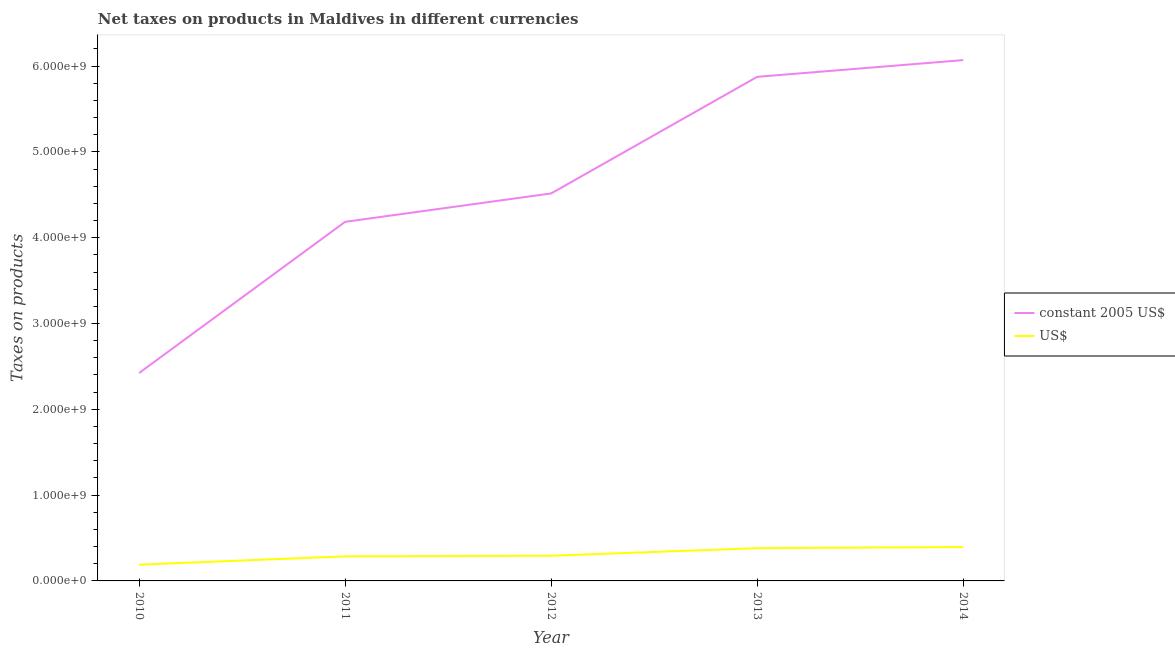What is the net taxes in constant 2005 us$ in 2012?
Your answer should be very brief. 4.52e+09. Across all years, what is the maximum net taxes in us$?
Provide a short and direct response. 3.94e+08. Across all years, what is the minimum net taxes in us$?
Your response must be concise. 1.89e+08. In which year was the net taxes in us$ maximum?
Make the answer very short. 2014. What is the total net taxes in us$ in the graph?
Provide a short and direct response. 1.55e+09. What is the difference between the net taxes in us$ in 2011 and that in 2014?
Give a very brief answer. -1.08e+08. What is the difference between the net taxes in us$ in 2013 and the net taxes in constant 2005 us$ in 2014?
Your answer should be compact. -5.69e+09. What is the average net taxes in constant 2005 us$ per year?
Your answer should be very brief. 4.61e+09. In the year 2013, what is the difference between the net taxes in constant 2005 us$ and net taxes in us$?
Keep it short and to the point. 5.49e+09. What is the ratio of the net taxes in us$ in 2011 to that in 2014?
Ensure brevity in your answer.  0.73. Is the difference between the net taxes in constant 2005 us$ in 2010 and 2013 greater than the difference between the net taxes in us$ in 2010 and 2013?
Your response must be concise. No. What is the difference between the highest and the second highest net taxes in constant 2005 us$?
Offer a terse response. 1.95e+08. What is the difference between the highest and the lowest net taxes in constant 2005 us$?
Make the answer very short. 3.65e+09. Is the sum of the net taxes in us$ in 2010 and 2014 greater than the maximum net taxes in constant 2005 us$ across all years?
Your answer should be very brief. No. Does the net taxes in us$ monotonically increase over the years?
Ensure brevity in your answer.  Yes. Is the net taxes in us$ strictly greater than the net taxes in constant 2005 us$ over the years?
Your answer should be compact. No. How many years are there in the graph?
Ensure brevity in your answer.  5. What is the difference between two consecutive major ticks on the Y-axis?
Make the answer very short. 1.00e+09. Does the graph contain any zero values?
Keep it short and to the point. No. Where does the legend appear in the graph?
Your answer should be compact. Center right. What is the title of the graph?
Your response must be concise. Net taxes on products in Maldives in different currencies. What is the label or title of the X-axis?
Keep it short and to the point. Year. What is the label or title of the Y-axis?
Your answer should be compact. Taxes on products. What is the Taxes on products in constant 2005 US$ in 2010?
Provide a short and direct response. 2.42e+09. What is the Taxes on products in US$ in 2010?
Give a very brief answer. 1.89e+08. What is the Taxes on products of constant 2005 US$ in 2011?
Provide a short and direct response. 4.18e+09. What is the Taxes on products of US$ in 2011?
Ensure brevity in your answer.  2.87e+08. What is the Taxes on products of constant 2005 US$ in 2012?
Ensure brevity in your answer.  4.52e+09. What is the Taxes on products in US$ in 2012?
Give a very brief answer. 2.93e+08. What is the Taxes on products of constant 2005 US$ in 2013?
Keep it short and to the point. 5.88e+09. What is the Taxes on products of US$ in 2013?
Your answer should be compact. 3.82e+08. What is the Taxes on products in constant 2005 US$ in 2014?
Give a very brief answer. 6.07e+09. What is the Taxes on products of US$ in 2014?
Offer a very short reply. 3.94e+08. Across all years, what is the maximum Taxes on products of constant 2005 US$?
Ensure brevity in your answer.  6.07e+09. Across all years, what is the maximum Taxes on products of US$?
Give a very brief answer. 3.94e+08. Across all years, what is the minimum Taxes on products in constant 2005 US$?
Your answer should be very brief. 2.42e+09. Across all years, what is the minimum Taxes on products in US$?
Give a very brief answer. 1.89e+08. What is the total Taxes on products in constant 2005 US$ in the graph?
Provide a short and direct response. 2.31e+1. What is the total Taxes on products of US$ in the graph?
Keep it short and to the point. 1.55e+09. What is the difference between the Taxes on products in constant 2005 US$ in 2010 and that in 2011?
Provide a succinct answer. -1.76e+09. What is the difference between the Taxes on products in US$ in 2010 and that in 2011?
Provide a short and direct response. -9.73e+07. What is the difference between the Taxes on products in constant 2005 US$ in 2010 and that in 2012?
Provide a short and direct response. -2.09e+09. What is the difference between the Taxes on products of US$ in 2010 and that in 2012?
Make the answer very short. -1.04e+08. What is the difference between the Taxes on products in constant 2005 US$ in 2010 and that in 2013?
Make the answer very short. -3.45e+09. What is the difference between the Taxes on products in US$ in 2010 and that in 2013?
Your response must be concise. -1.92e+08. What is the difference between the Taxes on products in constant 2005 US$ in 2010 and that in 2014?
Provide a succinct answer. -3.65e+09. What is the difference between the Taxes on products in US$ in 2010 and that in 2014?
Your answer should be very brief. -2.05e+08. What is the difference between the Taxes on products of constant 2005 US$ in 2011 and that in 2012?
Provide a short and direct response. -3.31e+08. What is the difference between the Taxes on products of US$ in 2011 and that in 2012?
Keep it short and to the point. -6.82e+06. What is the difference between the Taxes on products of constant 2005 US$ in 2011 and that in 2013?
Make the answer very short. -1.69e+09. What is the difference between the Taxes on products of US$ in 2011 and that in 2013?
Offer a terse response. -9.51e+07. What is the difference between the Taxes on products of constant 2005 US$ in 2011 and that in 2014?
Offer a terse response. -1.88e+09. What is the difference between the Taxes on products in US$ in 2011 and that in 2014?
Make the answer very short. -1.08e+08. What is the difference between the Taxes on products in constant 2005 US$ in 2012 and that in 2013?
Ensure brevity in your answer.  -1.36e+09. What is the difference between the Taxes on products of US$ in 2012 and that in 2013?
Provide a succinct answer. -8.83e+07. What is the difference between the Taxes on products of constant 2005 US$ in 2012 and that in 2014?
Ensure brevity in your answer.  -1.55e+09. What is the difference between the Taxes on products of US$ in 2012 and that in 2014?
Your response must be concise. -1.01e+08. What is the difference between the Taxes on products in constant 2005 US$ in 2013 and that in 2014?
Provide a succinct answer. -1.95e+08. What is the difference between the Taxes on products of US$ in 2013 and that in 2014?
Offer a terse response. -1.27e+07. What is the difference between the Taxes on products in constant 2005 US$ in 2010 and the Taxes on products in US$ in 2011?
Provide a succinct answer. 2.14e+09. What is the difference between the Taxes on products in constant 2005 US$ in 2010 and the Taxes on products in US$ in 2012?
Make the answer very short. 2.13e+09. What is the difference between the Taxes on products in constant 2005 US$ in 2010 and the Taxes on products in US$ in 2013?
Your answer should be compact. 2.04e+09. What is the difference between the Taxes on products of constant 2005 US$ in 2010 and the Taxes on products of US$ in 2014?
Make the answer very short. 2.03e+09. What is the difference between the Taxes on products of constant 2005 US$ in 2011 and the Taxes on products of US$ in 2012?
Ensure brevity in your answer.  3.89e+09. What is the difference between the Taxes on products of constant 2005 US$ in 2011 and the Taxes on products of US$ in 2013?
Your answer should be compact. 3.80e+09. What is the difference between the Taxes on products in constant 2005 US$ in 2011 and the Taxes on products in US$ in 2014?
Offer a terse response. 3.79e+09. What is the difference between the Taxes on products in constant 2005 US$ in 2012 and the Taxes on products in US$ in 2013?
Offer a very short reply. 4.13e+09. What is the difference between the Taxes on products of constant 2005 US$ in 2012 and the Taxes on products of US$ in 2014?
Your answer should be very brief. 4.12e+09. What is the difference between the Taxes on products of constant 2005 US$ in 2013 and the Taxes on products of US$ in 2014?
Your answer should be compact. 5.48e+09. What is the average Taxes on products of constant 2005 US$ per year?
Offer a very short reply. 4.61e+09. What is the average Taxes on products of US$ per year?
Keep it short and to the point. 3.09e+08. In the year 2010, what is the difference between the Taxes on products in constant 2005 US$ and Taxes on products in US$?
Keep it short and to the point. 2.23e+09. In the year 2011, what is the difference between the Taxes on products of constant 2005 US$ and Taxes on products of US$?
Provide a succinct answer. 3.90e+09. In the year 2012, what is the difference between the Taxes on products in constant 2005 US$ and Taxes on products in US$?
Ensure brevity in your answer.  4.22e+09. In the year 2013, what is the difference between the Taxes on products of constant 2005 US$ and Taxes on products of US$?
Keep it short and to the point. 5.49e+09. In the year 2014, what is the difference between the Taxes on products of constant 2005 US$ and Taxes on products of US$?
Ensure brevity in your answer.  5.68e+09. What is the ratio of the Taxes on products in constant 2005 US$ in 2010 to that in 2011?
Offer a terse response. 0.58. What is the ratio of the Taxes on products in US$ in 2010 to that in 2011?
Keep it short and to the point. 0.66. What is the ratio of the Taxes on products in constant 2005 US$ in 2010 to that in 2012?
Provide a short and direct response. 0.54. What is the ratio of the Taxes on products in US$ in 2010 to that in 2012?
Keep it short and to the point. 0.65. What is the ratio of the Taxes on products in constant 2005 US$ in 2010 to that in 2013?
Offer a terse response. 0.41. What is the ratio of the Taxes on products in US$ in 2010 to that in 2013?
Provide a succinct answer. 0.5. What is the ratio of the Taxes on products in constant 2005 US$ in 2010 to that in 2014?
Keep it short and to the point. 0.4. What is the ratio of the Taxes on products of US$ in 2010 to that in 2014?
Provide a short and direct response. 0.48. What is the ratio of the Taxes on products in constant 2005 US$ in 2011 to that in 2012?
Your answer should be very brief. 0.93. What is the ratio of the Taxes on products of US$ in 2011 to that in 2012?
Ensure brevity in your answer.  0.98. What is the ratio of the Taxes on products of constant 2005 US$ in 2011 to that in 2013?
Keep it short and to the point. 0.71. What is the ratio of the Taxes on products in US$ in 2011 to that in 2013?
Your response must be concise. 0.75. What is the ratio of the Taxes on products in constant 2005 US$ in 2011 to that in 2014?
Provide a short and direct response. 0.69. What is the ratio of the Taxes on products of US$ in 2011 to that in 2014?
Provide a succinct answer. 0.73. What is the ratio of the Taxes on products of constant 2005 US$ in 2012 to that in 2013?
Offer a very short reply. 0.77. What is the ratio of the Taxes on products in US$ in 2012 to that in 2013?
Your answer should be compact. 0.77. What is the ratio of the Taxes on products of constant 2005 US$ in 2012 to that in 2014?
Your response must be concise. 0.74. What is the ratio of the Taxes on products in US$ in 2012 to that in 2014?
Your response must be concise. 0.74. What is the ratio of the Taxes on products of constant 2005 US$ in 2013 to that in 2014?
Keep it short and to the point. 0.97. What is the ratio of the Taxes on products of US$ in 2013 to that in 2014?
Offer a terse response. 0.97. What is the difference between the highest and the second highest Taxes on products of constant 2005 US$?
Your answer should be very brief. 1.95e+08. What is the difference between the highest and the second highest Taxes on products of US$?
Offer a very short reply. 1.27e+07. What is the difference between the highest and the lowest Taxes on products of constant 2005 US$?
Provide a short and direct response. 3.65e+09. What is the difference between the highest and the lowest Taxes on products of US$?
Your answer should be compact. 2.05e+08. 